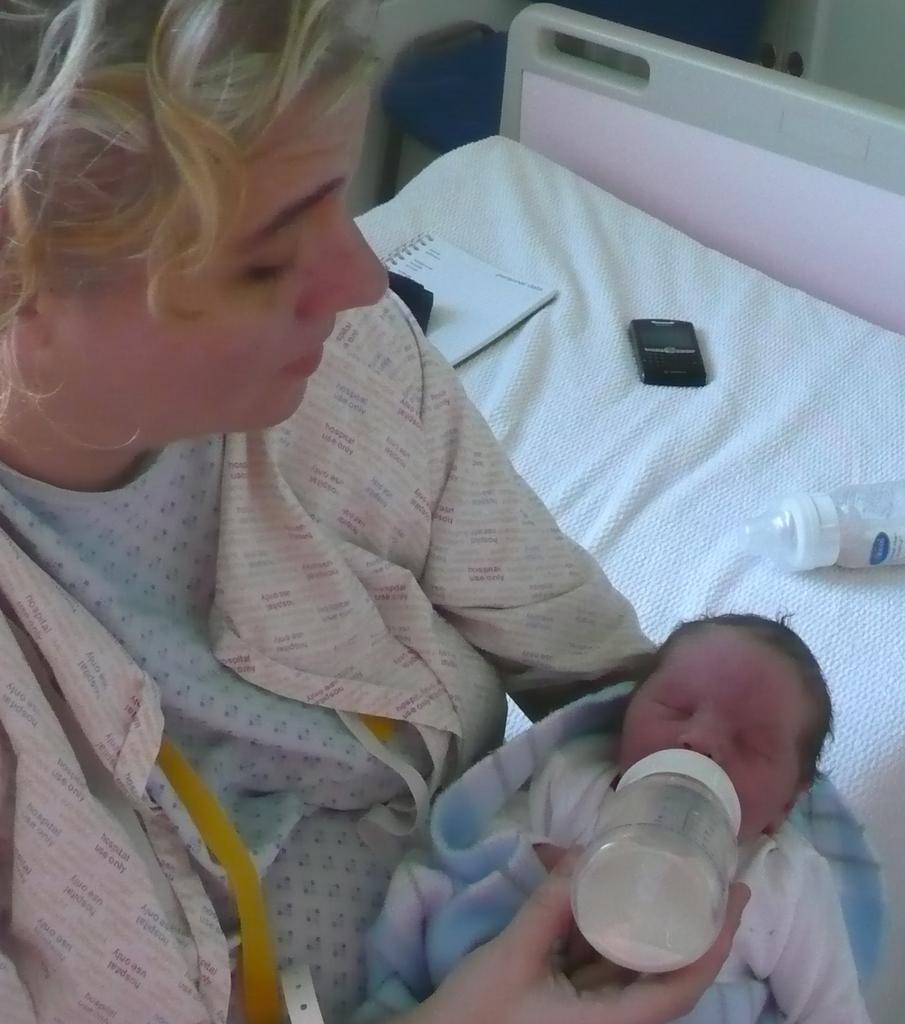Describe this image in one or two sentences. In the image we can see there is a woman who is sitting and she is feeding milk to the baby and on the bed there is a book, mobile phone and milk bottle. 